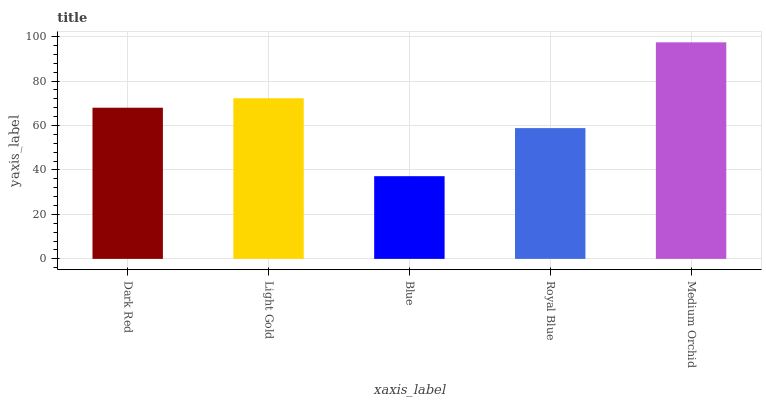Is Blue the minimum?
Answer yes or no. Yes. Is Medium Orchid the maximum?
Answer yes or no. Yes. Is Light Gold the minimum?
Answer yes or no. No. Is Light Gold the maximum?
Answer yes or no. No. Is Light Gold greater than Dark Red?
Answer yes or no. Yes. Is Dark Red less than Light Gold?
Answer yes or no. Yes. Is Dark Red greater than Light Gold?
Answer yes or no. No. Is Light Gold less than Dark Red?
Answer yes or no. No. Is Dark Red the high median?
Answer yes or no. Yes. Is Dark Red the low median?
Answer yes or no. Yes. Is Royal Blue the high median?
Answer yes or no. No. Is Light Gold the low median?
Answer yes or no. No. 